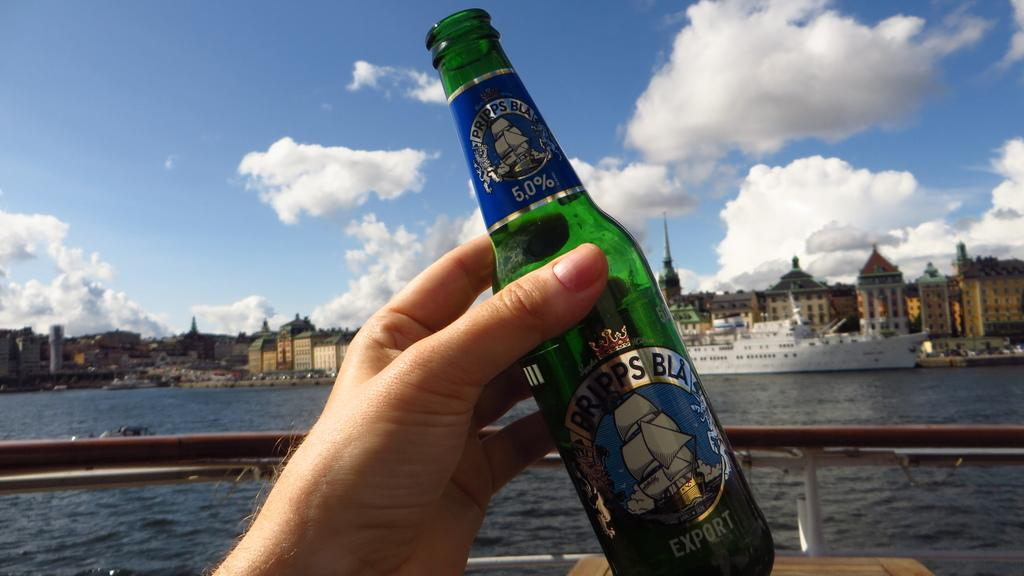<image>
Offer a succinct explanation of the picture presented. A person holds a bottle of Pripps Bla against a blue sky 